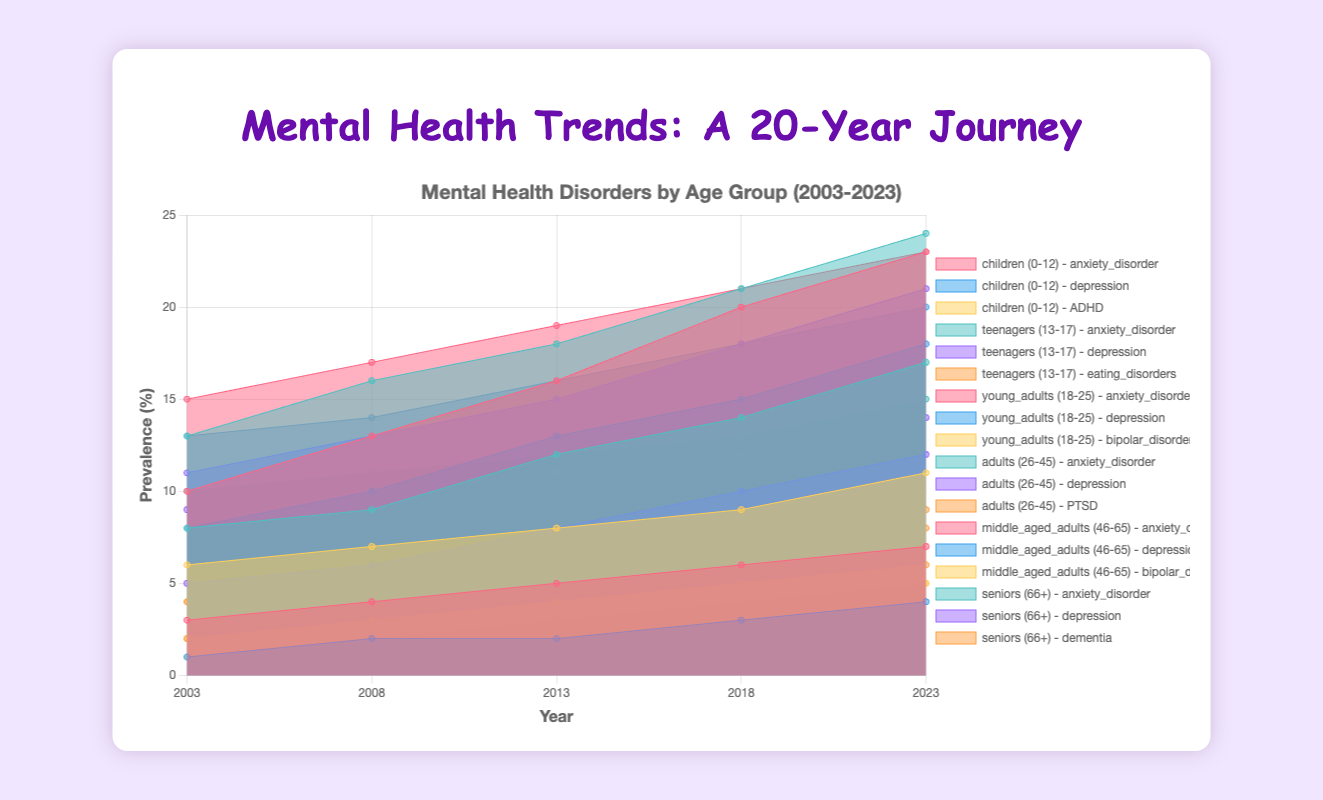What is the title of the chart? The title is usually displayed at the top of the chart. In this case, it can be found in the HTML `<h1>` tag and in the chart title settings.
Answer: Mental Health Trends: A 20-Year Journey What is the highest prevalence value for anxiety disorder among teenagers in 2023? Look at the values for "teenagers (13-17)" and the series labeled "anxiety_disorder." The prevalence in 2023 is 17.
Answer: 17 Which age group has the lowest prevalence of depression in 2003? Compare the values for depression across all age groups in 2003. Among children (0-12), the value is 1, which is the lowest.
Answer: children (0-12) How has the prevalence of ADHD in children (0–12) changed from 2003 to 2023? Look at the values for "ADHD" in the "children (0–12)" group for the years 2003 and 2023. Calculate the difference: 11 - 6 = 5.
Answer: Increased by 5 Which mental disorder has seen the greatest increase in young adults (18-25) from 2003 to 2023? Compare the changes in values for anxiety disorder, depression, and bipolar disorder in the "young adults (18-25)" group between 2003 and 2023. Anxiety disorder changes from 10 to 23, an increase of 13, which is the greatest among the three.
Answer: Anxiety disorder What is the prevalence of bipolar disorder in middle-aged adults (46-65) in 2023 compared to 2003? Look at the data for bipolar disorder in the "middle-aged adults (46-65)" group for the years 2003 and 2023. The values are 2 in 2003 and 5 in 2023.
Answer: Increased by 3 In which year did adults (26-45) have the highest prevalence of PTSD? Look at the values for PTSD in the "adults (26-45)" group. The highest value is 8, in the year 2023.
Answer: 2023 Which disorder among seniors (66+) has shown an increase every measured year from 2003 to 2023? Check each disorder (anxiety disorder, depression, dementia) across all years. Dementia shows consistent increases from 4 to 9.
Answer: Dementia What is the trend of depression in teenagers (13-17) over the 20 years? Analyze the values for "depression" in the "teenagers (13-17)" group over the given years: 5, 6, 8, 10, 12. It shows a consistent increase.
Answer: Increasing trend Compare the prevalence of anxiety disorder in young adults (18-25) and adults (26-45) in the year 2013. Which group has a higher prevalence? Look at the anxiety disorder value for both "young adults (18-25)" and "adults (26-45)" in the year 2013. Young adults have 16, and adults have 18. Adults (26-45) have a higher prevalence.
Answer: Adults (26-45) 